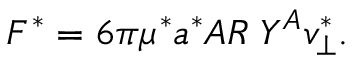<formula> <loc_0><loc_0><loc_500><loc_500>F ^ { * } = 6 \pi \mu ^ { * } a ^ { * } A R \, Y ^ { A } v _ { \bot } ^ { * } .</formula> 